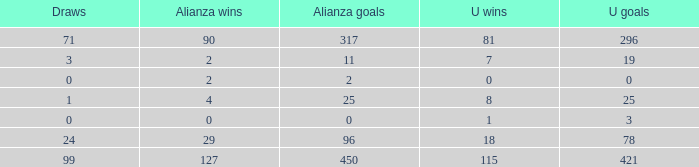What is the lowest U Wins, when Alianza Wins is greater than 0, when Alianza Goals is greater than 25, and when Draws is "99"? 115.0. 